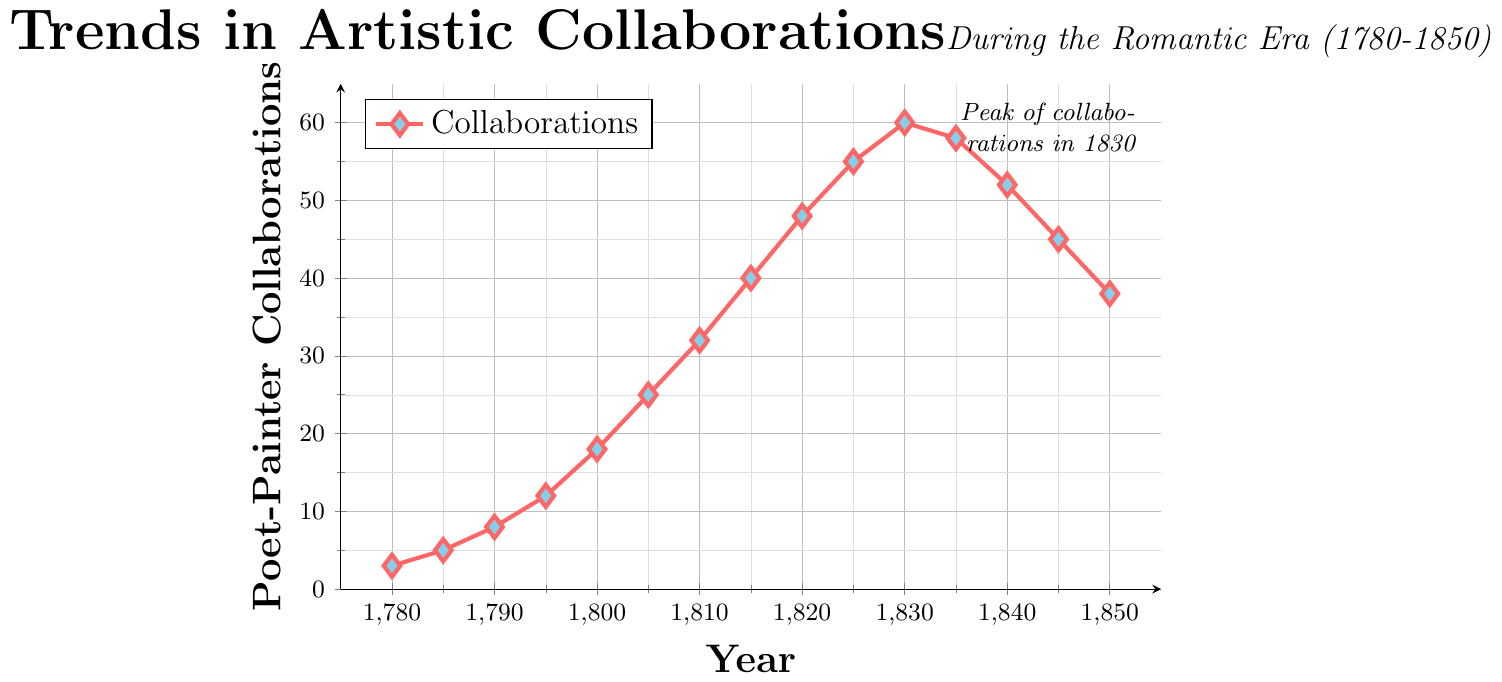What's the total number of collaborations from 1780 to 1850? Add all the values from 1780 to 1850: 3 + 5 + 8 + 12 + 18 + 25 + 32 + 40 + 48 + 55 + 60 + 58 + 52 + 45 + 38 = 499
Answer: 499 In which year did the number of collaborations peak? Look for the highest point in the plot, which occurs at 1830 with 60 collaborations
Answer: 1830 When did collaborations first surpass 30? Look for the first year where the value exceeds 30. The value reaches 32 in 1810
Answer: 1810 By how much did collaborations increase from 1780 to 1820? Subtract the number of collaborations in 1780 from that in 1820: 48 - 3 = 45
Answer: 45 How does the number of collaborations in 1850 compare to that in 1835? Compare the values in 1835 and 1850. In 1835, there are 58 collaborations, and in 1850, there are 38. 58 > 38
Answer: The number of collaborations in 1850 is less than in 1835 What's the average number of collaborations per year from 1780 to 1850? Divide the total number of collaborations (499) by the number of years (15): 499 / 15 ≈ 33.27
Answer: Approximately 33 Describe the trend in collaborations from 1800 to 1830. From 1800 to 1830, the collaborations steadily increase from 18 in 1800 to a peak of 60 in 1830
Answer: Increasing trend Which year experienced the largest increase in collaborations compared to the previous year? Determine the year-by-year differences and find the maximum: (1800-1795) = 6, (1805-1800) = 7, (1810-1805) = 7, (1815-1810) = 8, (1820-1815) = 8, (1825-1820) = 7, (1830-1825) = 5. The largest increase is 8 from 1810 to 1815, and from 1815 to 1820
Answer: 1815 What color represents the data points in the plot? Observe the plot to identify the color used for the data points; they are marked in red and blue
Answer: Red and blue 